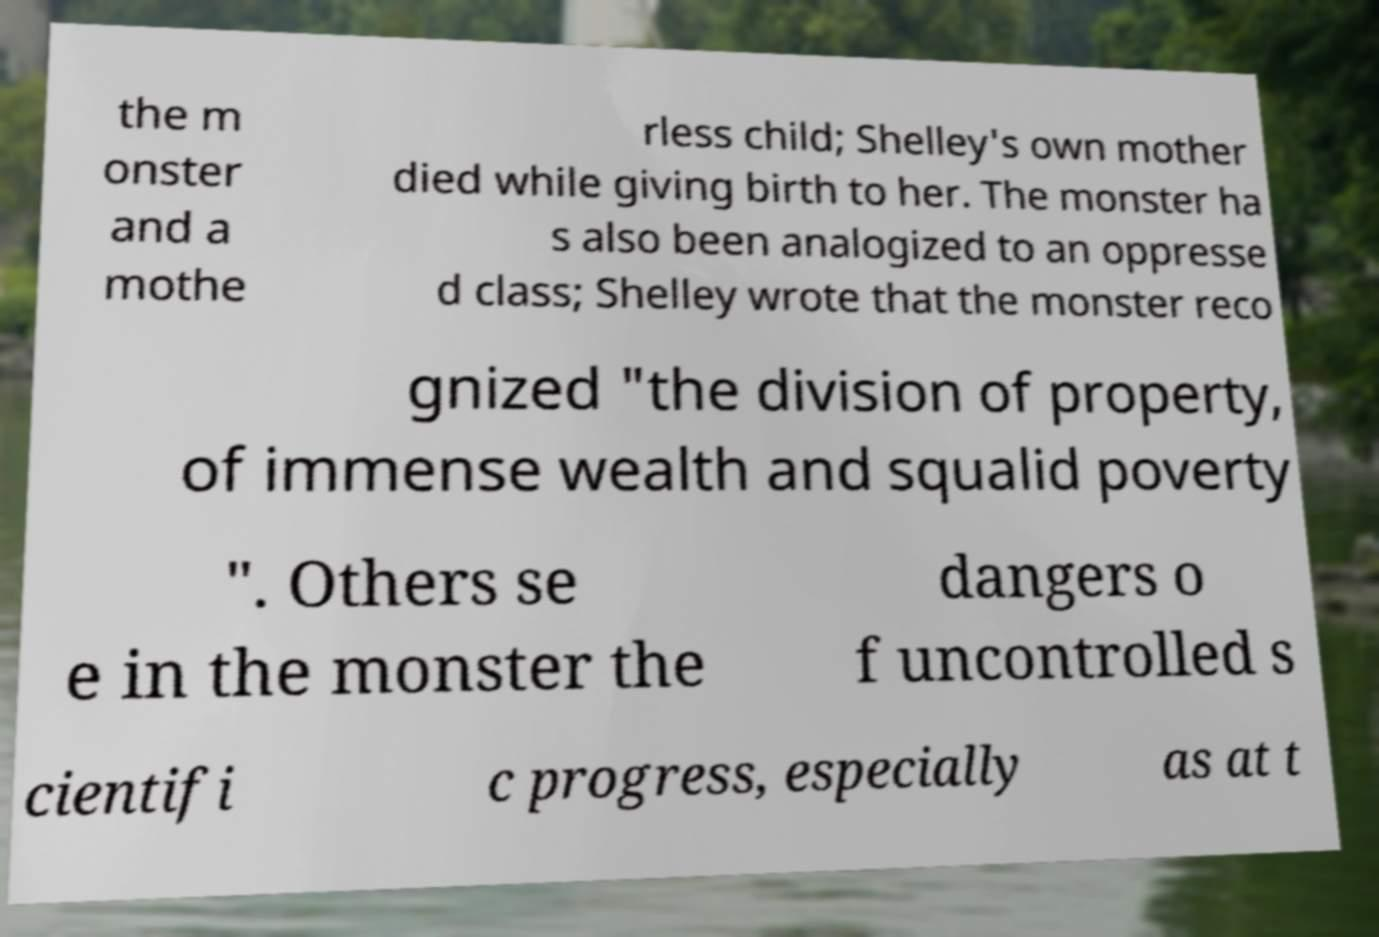Could you assist in decoding the text presented in this image and type it out clearly? the m onster and a mothe rless child; Shelley's own mother died while giving birth to her. The monster ha s also been analogized to an oppresse d class; Shelley wrote that the monster reco gnized "the division of property, of immense wealth and squalid poverty ". Others se e in the monster the dangers o f uncontrolled s cientifi c progress, especially as at t 